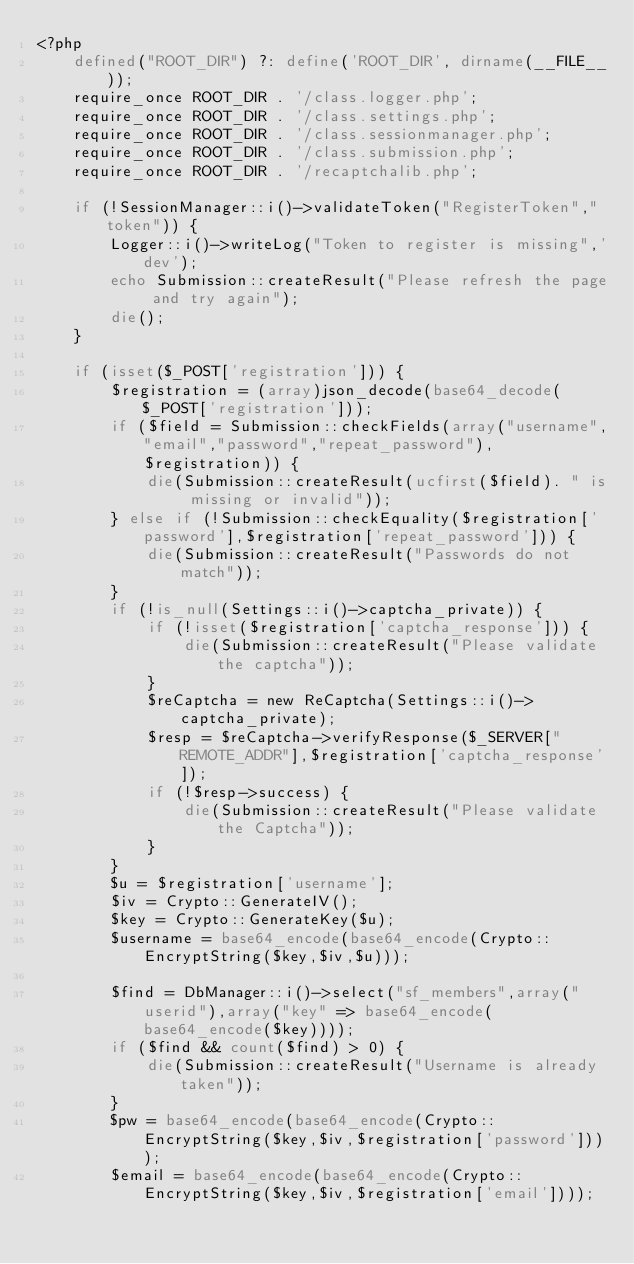Convert code to text. <code><loc_0><loc_0><loc_500><loc_500><_PHP_><?php
	defined("ROOT_DIR") ?: define('ROOT_DIR', dirname(__FILE__));
	require_once ROOT_DIR . '/class.logger.php';
	require_once ROOT_DIR . '/class.settings.php';
	require_once ROOT_DIR . '/class.sessionmanager.php';
	require_once ROOT_DIR . '/class.submission.php';
	require_once ROOT_DIR . '/recaptchalib.php';

	if (!SessionManager::i()->validateToken("RegisterToken","token")) {
		Logger::i()->writeLog("Token to register is missing",'dev');
		echo Submission::createResult("Please refresh the page and try again");
		die();
	}

	if (isset($_POST['registration'])) {
		$registration = (array)json_decode(base64_decode($_POST['registration']));
		if ($field = Submission::checkFields(array("username","email","password","repeat_password"),$registration)) {
			die(Submission::createResult(ucfirst($field). " is missing or invalid"));
		} else if (!Submission::checkEquality($registration['password'],$registration['repeat_password'])) {
			die(Submission::createResult("Passwords do not match"));
		}
		if (!is_null(Settings::i()->captcha_private)) {
			if (!isset($registration['captcha_response'])) {
				die(Submission::createResult("Please validate the captcha"));
			}
			$reCaptcha = new ReCaptcha(Settings::i()->captcha_private);
			$resp = $reCaptcha->verifyResponse($_SERVER["REMOTE_ADDR"],$registration['captcha_response']);
			if (!$resp->success) {
				die(Submission::createResult("Please validate the Captcha"));
			}
		}
		$u = $registration['username'];
		$iv = Crypto::GenerateIV();
		$key = Crypto::GenerateKey($u);
		$username = base64_encode(base64_encode(Crypto::EncryptString($key,$iv,$u)));

		$find = DbManager::i()->select("sf_members",array("userid"),array("key" => base64_encode(base64_encode($key))));
		if ($find && count($find) > 0) {
			die(Submission::createResult("Username is already taken"));
		}
		$pw = base64_encode(base64_encode(Crypto::EncryptString($key,$iv,$registration['password'])));
		$email = base64_encode(base64_encode(Crypto::EncryptString($key,$iv,$registration['email'])));</code> 